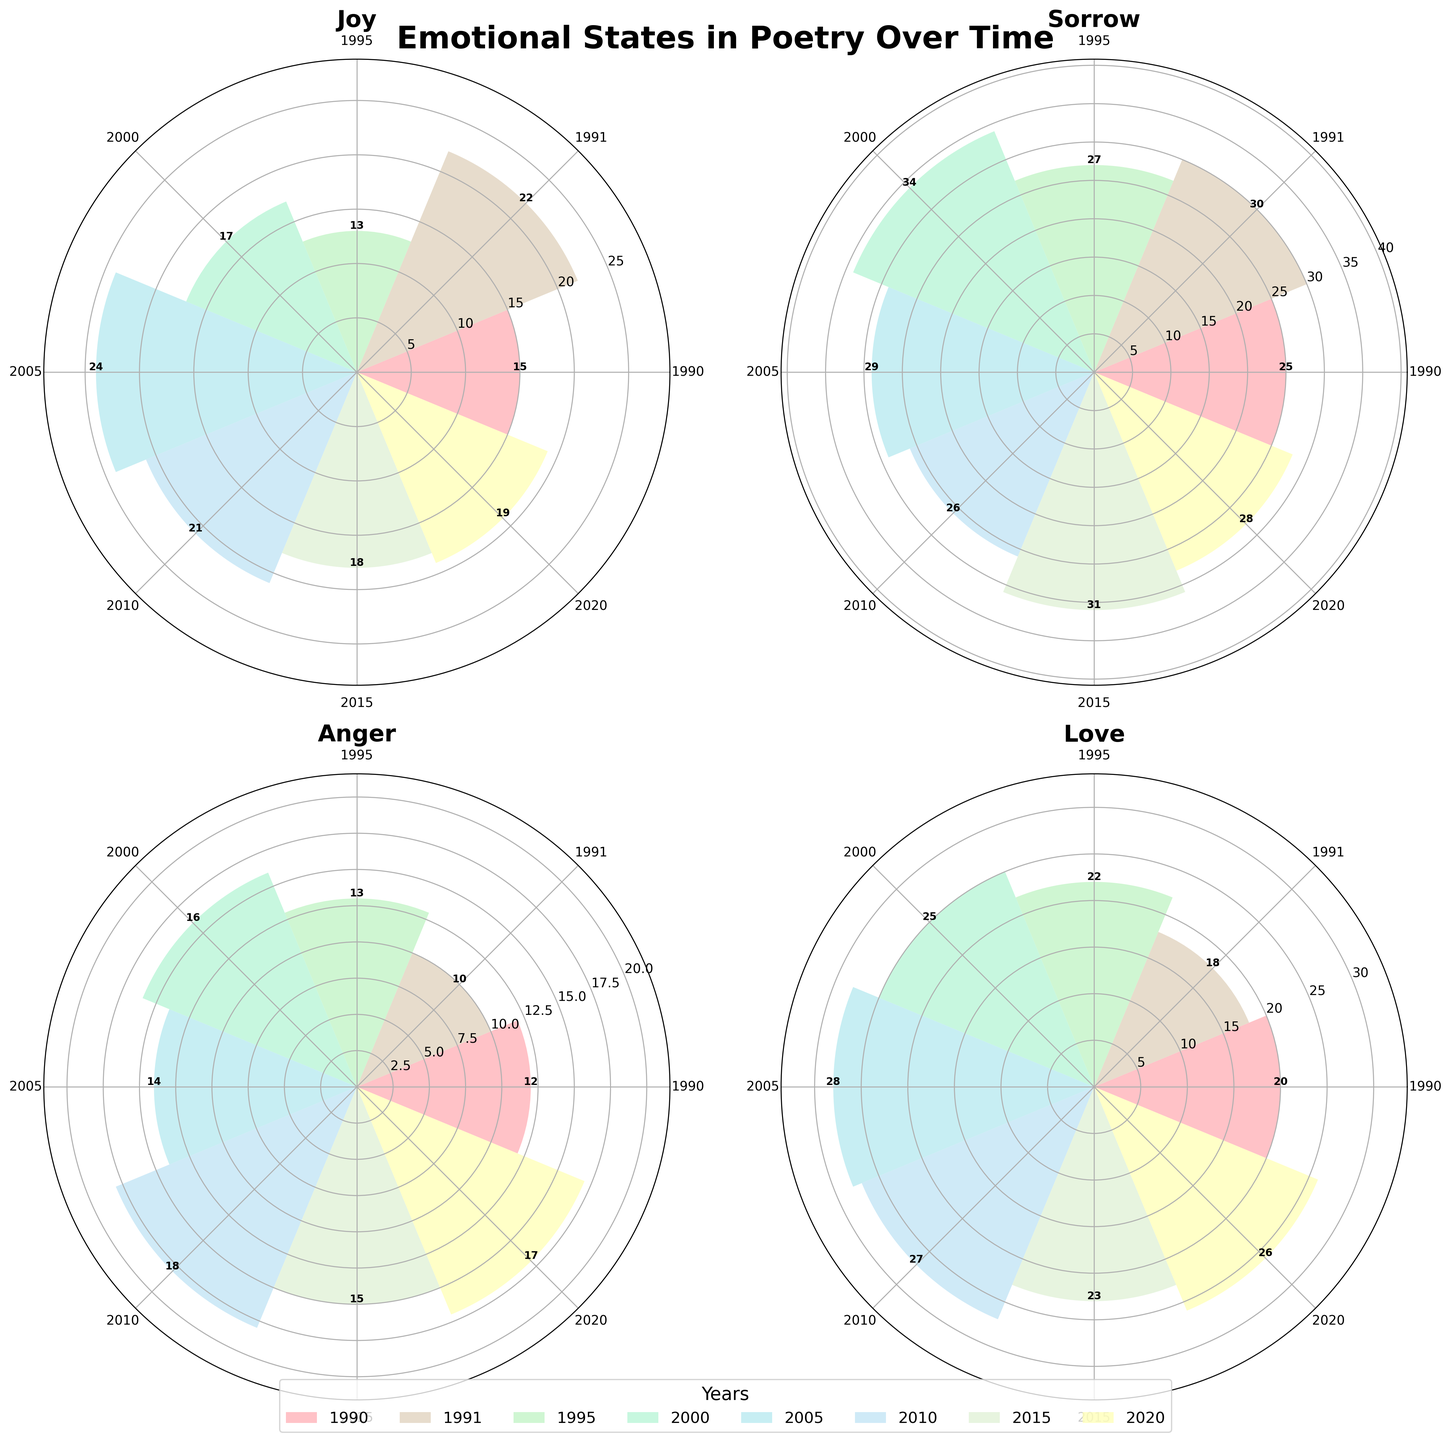How many emotional states are captured in the figure? The figure has four subplots, each with a specific title. These titles represent the different emotional states.
Answer: 4 What is the title of the figure? The title is prominently displayed at the top of the figure.
Answer: Emotional States in Poetry Over Time Which emotional category has the highest count in the year 2000? Each subplot has markers for each year, and the radial length (height of the bars) indicates the count. By comparing the bars for the year 2000 across subplots, the highest bar belongs to Sorrow.
Answer: Sorrow Which year has the lowest count for Anger? Each bar in the Anger subplot represents a specific year. By comparing these bars, the shortest bar indicates the year with the lowest count.
Answer: 1991 How does the count of Joy in 1995 compare to 2005? In the Joy subplot, check the height of the bars for the years 1995 and 2005. The bar for 2005 is higher.
Answer: 2005 is higher What's the trend of the Sorrow category from 1990 to 2020? By observing the lengths of the bars in the Sorrow subplot from 1990 to 2020, you can see the changes over the years. Initially, there is a rise, then a slight dip, and some fluctuations.
Answer: Fluctuating with initial rise Which category experienced the largest increase in count from 1990 to 2005? For each subplot, calculate the increase from 1990 to 2005 by comparing the bar heights. The largest difference is observed in Love.
Answer: Love Compare the counts of Love in 1990 and 2020 and discuss the difference. In the Love subplot, compare the bar lengths for 1990 and 2020. The bar for 2020 is longer.
Answer: 2020 is higher by 6 What is the overall trend observed in the Joy category over the 30-year period? Observe the changes in bar heights in the Joy subplot from 1990 to 2020. There are some fluctuations but an overall moderate level.
Answer: Generally fluctuating around similar values In which year did the count for Sorrow reach its peak? The highest bar in the Sorrow subplot will indicate the year with the highest count.
Answer: 2000 